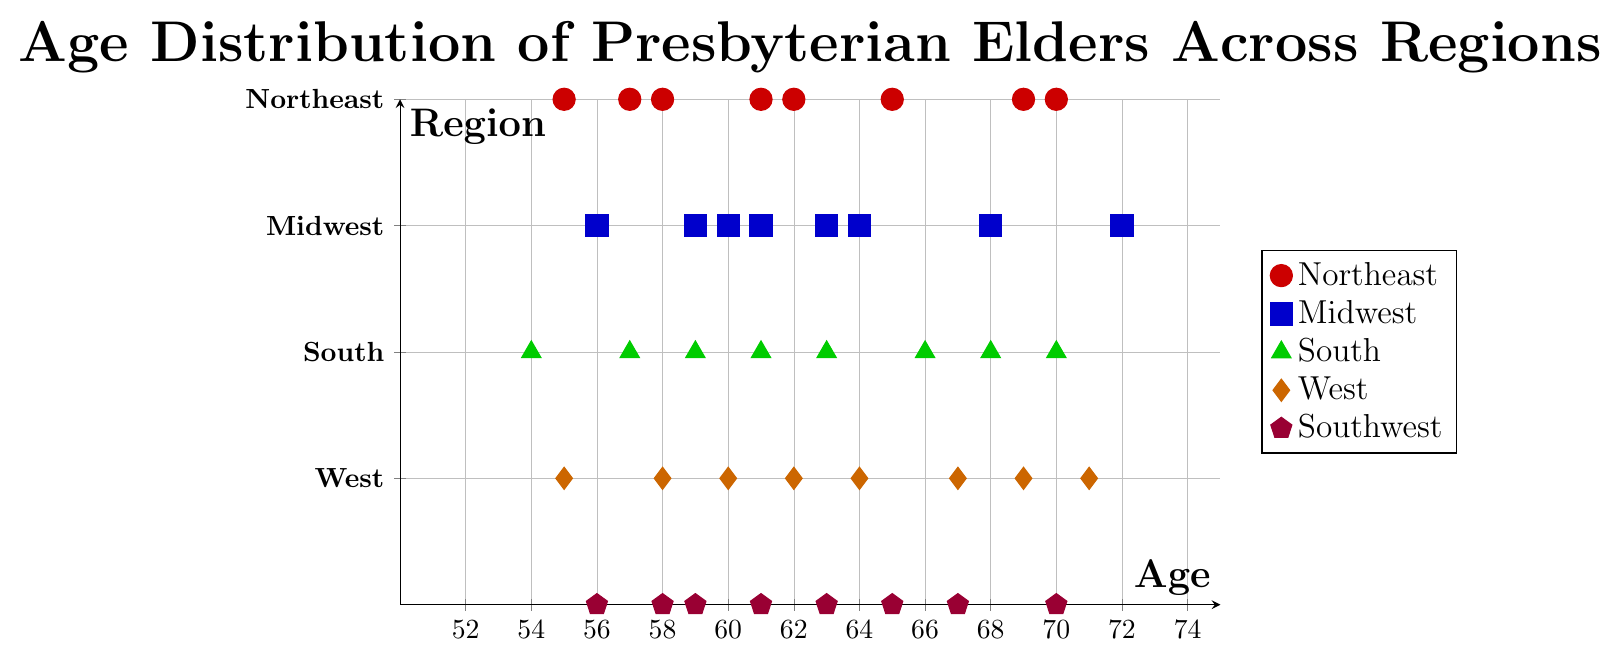What is the range of ages for elders in the Northeast region? The lowest age in the Northeast region is 55, and the highest age is 70. Therefore, the range is 70 - 55 = 15.
Answer: 15 Which region has the elder with the highest age? The highest age in the plot is 72, which is located in the Midwest region, according to the figure.
Answer: Midwest How does the median age of elders in the South region compare to that in the West region? The median age is the middle value when the ages are ordered. Sorting ages in the South: 54, 57, 59, 61, 63, 66, 68, 70. The median is the average of the 4th and 5th values: (61+63)/2 = 62. Sorting ages in the West: 55, 58, 60, 62, 64, 67, 69, 71. The median is the average of the 4th and 5th values: (62+64)/2 = 63. Therefore, the median age in the South is 62, and in the West, it is 63.
Answer: In the South: 62, In the West: 63 Which region has the most concentrated age distribution among its elders? The concentration of ages can be measured by examining how closely the ages are clustered. The Southwest has the most clustered ages ranging from 56-70, with repeated values indicating no wide gaps between ages. The other regions have a wider distribution.
Answer: Southwest Identify all the unique age values represented by elders in the Midwest region. The ages in the Midwest as per the plot are: 59, 63, 68, 56, 61, 72, 60, and 64. Listing the unique values: 59, 63, 68, 56, 61, 72, 60, 64.
Answer: 56, 59, 60, 61, 63, 64, 68, 72 Which region has the youngest elder? The youngest elder is 54 years old, and they are from the South region according to the plot.
Answer: South What are the average ages of elders in the Northeast and the Southwest regions? For the Northeast: Sum = 62 + 58 + 65 + 70 + 55 + 61 + 69 + 57 = 497. Average = 497/8 = 62.125. For the Southwest: Sum = 59 + 63 + 67 + 56 + 61 + 70 + 65 + 58 = 499. Average = 499/8 = 62.375.
Answer: Northeast: 62.125, Southwest: 62.375 How many elders are there in the West region? By counting the number of data points in the West region shown in the figure, there are 8 elders.
Answer: 8 